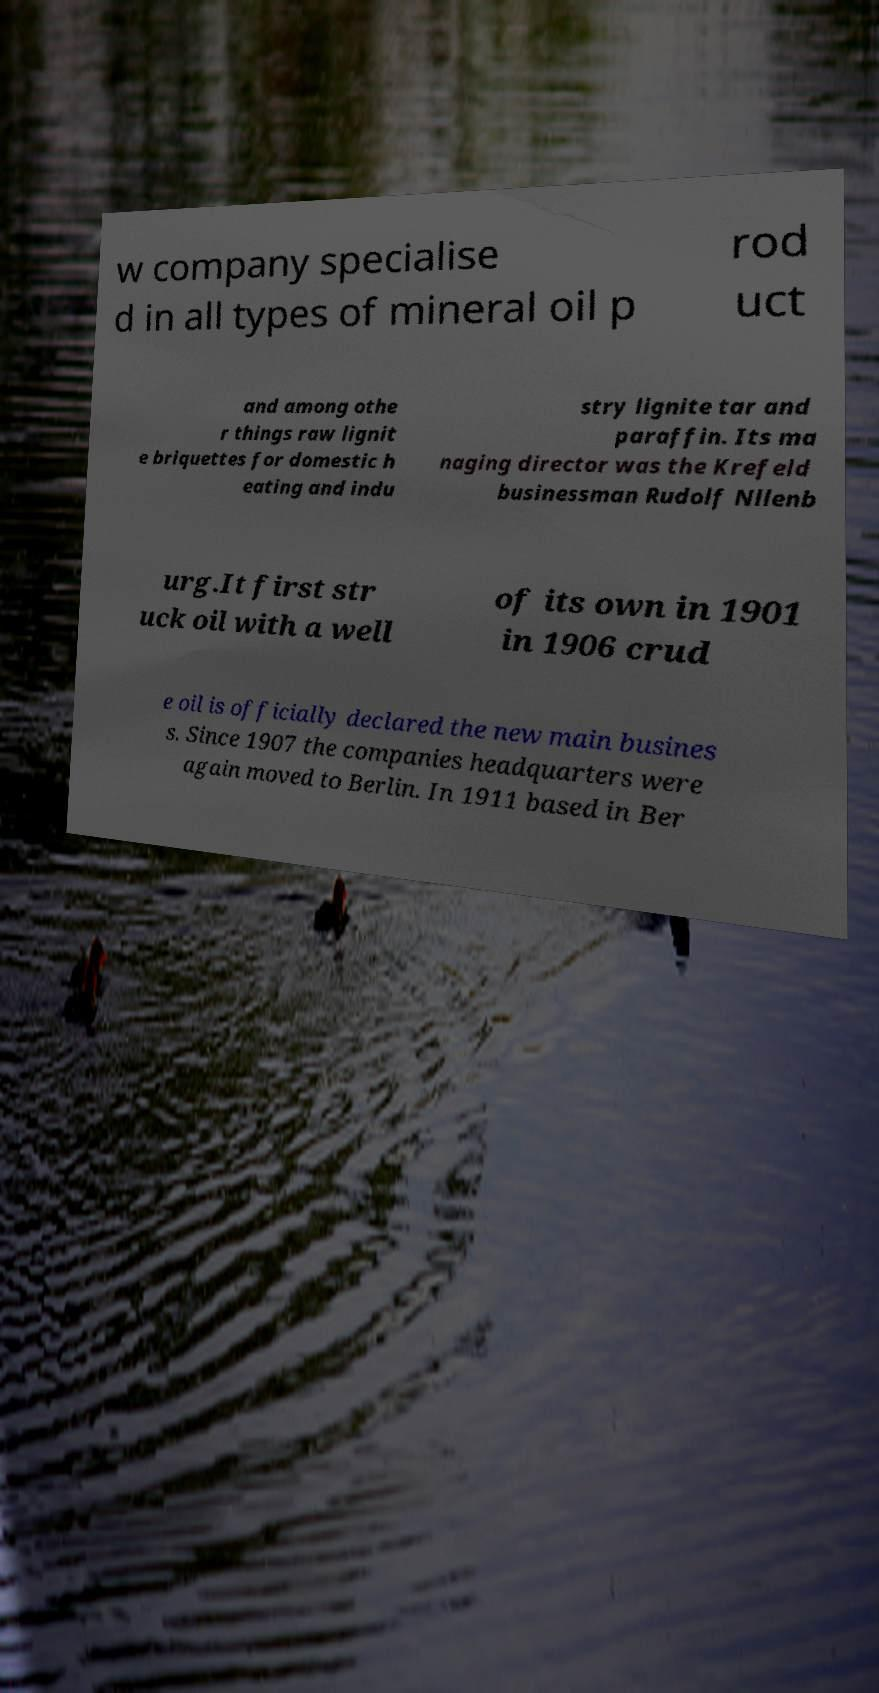What messages or text are displayed in this image? I need them in a readable, typed format. w company specialise d in all types of mineral oil p rod uct and among othe r things raw lignit e briquettes for domestic h eating and indu stry lignite tar and paraffin. Its ma naging director was the Krefeld businessman Rudolf Nllenb urg.It first str uck oil with a well of its own in 1901 in 1906 crud e oil is officially declared the new main busines s. Since 1907 the companies headquarters were again moved to Berlin. In 1911 based in Ber 